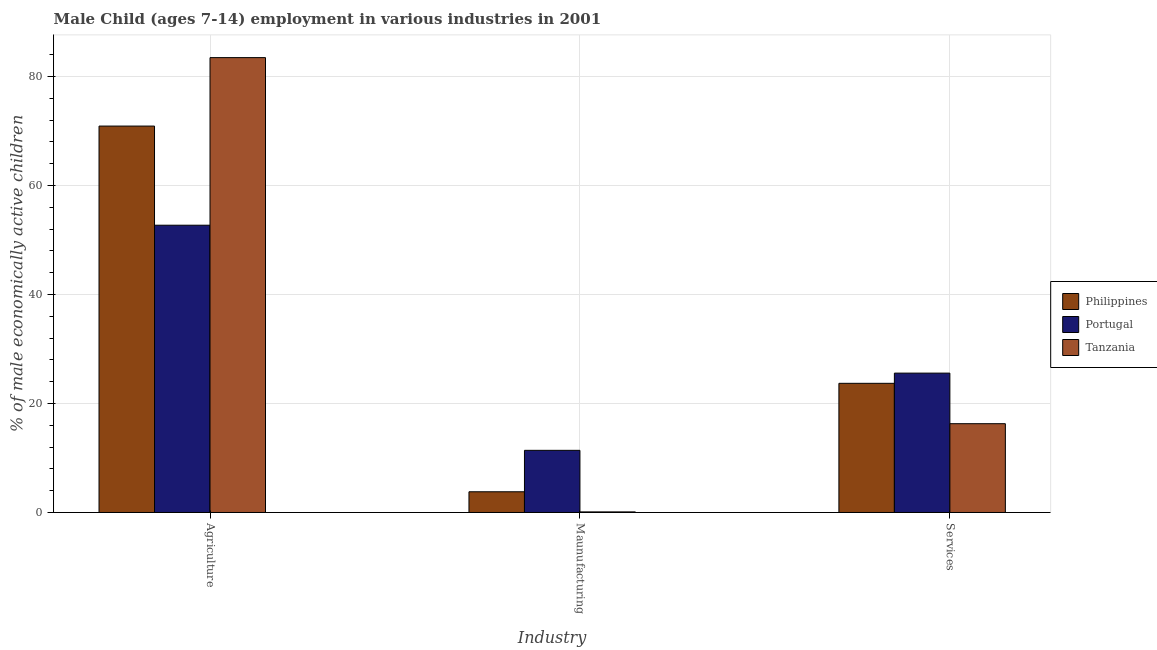How many groups of bars are there?
Ensure brevity in your answer.  3. Are the number of bars on each tick of the X-axis equal?
Your answer should be very brief. Yes. How many bars are there on the 1st tick from the right?
Keep it short and to the point. 3. What is the label of the 3rd group of bars from the left?
Give a very brief answer. Services. What is the percentage of economically active children in agriculture in Portugal?
Provide a short and direct response. 52.71. Across all countries, what is the maximum percentage of economically active children in services?
Make the answer very short. 25.57. Across all countries, what is the minimum percentage of economically active children in manufacturing?
Ensure brevity in your answer.  0.11. In which country was the percentage of economically active children in agriculture maximum?
Keep it short and to the point. Tanzania. In which country was the percentage of economically active children in services minimum?
Your answer should be compact. Tanzania. What is the total percentage of economically active children in manufacturing in the graph?
Ensure brevity in your answer.  15.31. What is the difference between the percentage of economically active children in agriculture in Portugal and that in Philippines?
Ensure brevity in your answer.  -18.19. What is the difference between the percentage of economically active children in services in Philippines and the percentage of economically active children in manufacturing in Portugal?
Provide a short and direct response. 12.3. What is the average percentage of economically active children in services per country?
Your answer should be compact. 21.85. What is the difference between the percentage of economically active children in services and percentage of economically active children in agriculture in Portugal?
Offer a terse response. -27.14. In how many countries, is the percentage of economically active children in services greater than 20 %?
Provide a succinct answer. 2. What is the ratio of the percentage of economically active children in manufacturing in Philippines to that in Portugal?
Your answer should be very brief. 0.33. Is the percentage of economically active children in services in Philippines less than that in Tanzania?
Offer a very short reply. No. Is the difference between the percentage of economically active children in agriculture in Portugal and Philippines greater than the difference between the percentage of economically active children in services in Portugal and Philippines?
Your answer should be very brief. No. What is the difference between the highest and the second highest percentage of economically active children in services?
Ensure brevity in your answer.  1.87. What is the difference between the highest and the lowest percentage of economically active children in agriculture?
Offer a very short reply. 30.75. In how many countries, is the percentage of economically active children in manufacturing greater than the average percentage of economically active children in manufacturing taken over all countries?
Ensure brevity in your answer.  1. Is the sum of the percentage of economically active children in manufacturing in Tanzania and Portugal greater than the maximum percentage of economically active children in agriculture across all countries?
Offer a very short reply. No. What does the 3rd bar from the left in Agriculture represents?
Make the answer very short. Tanzania. What does the 1st bar from the right in Services represents?
Your answer should be compact. Tanzania. Is it the case that in every country, the sum of the percentage of economically active children in agriculture and percentage of economically active children in manufacturing is greater than the percentage of economically active children in services?
Ensure brevity in your answer.  Yes. How many bars are there?
Offer a terse response. 9. Are all the bars in the graph horizontal?
Your answer should be compact. No. What is the difference between two consecutive major ticks on the Y-axis?
Provide a short and direct response. 20. What is the title of the graph?
Make the answer very short. Male Child (ages 7-14) employment in various industries in 2001. Does "Chile" appear as one of the legend labels in the graph?
Your answer should be very brief. No. What is the label or title of the X-axis?
Provide a short and direct response. Industry. What is the label or title of the Y-axis?
Keep it short and to the point. % of male economically active children. What is the % of male economically active children in Philippines in Agriculture?
Offer a very short reply. 70.9. What is the % of male economically active children in Portugal in Agriculture?
Offer a very short reply. 52.71. What is the % of male economically active children of Tanzania in Agriculture?
Your answer should be very brief. 83.46. What is the % of male economically active children of Portugal in Maunufacturing?
Provide a short and direct response. 11.4. What is the % of male economically active children in Tanzania in Maunufacturing?
Provide a short and direct response. 0.11. What is the % of male economically active children of Philippines in Services?
Offer a very short reply. 23.7. What is the % of male economically active children in Portugal in Services?
Offer a terse response. 25.57. What is the % of male economically active children of Tanzania in Services?
Offer a terse response. 16.29. Across all Industry, what is the maximum % of male economically active children of Philippines?
Offer a terse response. 70.9. Across all Industry, what is the maximum % of male economically active children in Portugal?
Provide a succinct answer. 52.71. Across all Industry, what is the maximum % of male economically active children of Tanzania?
Offer a very short reply. 83.46. Across all Industry, what is the minimum % of male economically active children of Philippines?
Provide a short and direct response. 3.8. Across all Industry, what is the minimum % of male economically active children of Portugal?
Offer a very short reply. 11.4. Across all Industry, what is the minimum % of male economically active children of Tanzania?
Give a very brief answer. 0.11. What is the total % of male economically active children of Philippines in the graph?
Keep it short and to the point. 98.4. What is the total % of male economically active children of Portugal in the graph?
Ensure brevity in your answer.  89.68. What is the total % of male economically active children of Tanzania in the graph?
Keep it short and to the point. 99.86. What is the difference between the % of male economically active children of Philippines in Agriculture and that in Maunufacturing?
Provide a succinct answer. 67.1. What is the difference between the % of male economically active children of Portugal in Agriculture and that in Maunufacturing?
Provide a short and direct response. 41.31. What is the difference between the % of male economically active children in Tanzania in Agriculture and that in Maunufacturing?
Offer a very short reply. 83.35. What is the difference between the % of male economically active children in Philippines in Agriculture and that in Services?
Offer a very short reply. 47.2. What is the difference between the % of male economically active children in Portugal in Agriculture and that in Services?
Keep it short and to the point. 27.14. What is the difference between the % of male economically active children of Tanzania in Agriculture and that in Services?
Your answer should be very brief. 67.17. What is the difference between the % of male economically active children in Philippines in Maunufacturing and that in Services?
Your answer should be compact. -19.9. What is the difference between the % of male economically active children in Portugal in Maunufacturing and that in Services?
Ensure brevity in your answer.  -14.17. What is the difference between the % of male economically active children in Tanzania in Maunufacturing and that in Services?
Give a very brief answer. -16.18. What is the difference between the % of male economically active children of Philippines in Agriculture and the % of male economically active children of Portugal in Maunufacturing?
Ensure brevity in your answer.  59.5. What is the difference between the % of male economically active children of Philippines in Agriculture and the % of male economically active children of Tanzania in Maunufacturing?
Keep it short and to the point. 70.79. What is the difference between the % of male economically active children in Portugal in Agriculture and the % of male economically active children in Tanzania in Maunufacturing?
Provide a succinct answer. 52.6. What is the difference between the % of male economically active children in Philippines in Agriculture and the % of male economically active children in Portugal in Services?
Give a very brief answer. 45.33. What is the difference between the % of male economically active children in Philippines in Agriculture and the % of male economically active children in Tanzania in Services?
Keep it short and to the point. 54.61. What is the difference between the % of male economically active children of Portugal in Agriculture and the % of male economically active children of Tanzania in Services?
Keep it short and to the point. 36.42. What is the difference between the % of male economically active children in Philippines in Maunufacturing and the % of male economically active children in Portugal in Services?
Your response must be concise. -21.77. What is the difference between the % of male economically active children in Philippines in Maunufacturing and the % of male economically active children in Tanzania in Services?
Ensure brevity in your answer.  -12.49. What is the difference between the % of male economically active children in Portugal in Maunufacturing and the % of male economically active children in Tanzania in Services?
Your answer should be compact. -4.89. What is the average % of male economically active children of Philippines per Industry?
Your response must be concise. 32.8. What is the average % of male economically active children of Portugal per Industry?
Keep it short and to the point. 29.89. What is the average % of male economically active children of Tanzania per Industry?
Provide a short and direct response. 33.29. What is the difference between the % of male economically active children of Philippines and % of male economically active children of Portugal in Agriculture?
Ensure brevity in your answer.  18.19. What is the difference between the % of male economically active children of Philippines and % of male economically active children of Tanzania in Agriculture?
Offer a terse response. -12.56. What is the difference between the % of male economically active children of Portugal and % of male economically active children of Tanzania in Agriculture?
Make the answer very short. -30.75. What is the difference between the % of male economically active children in Philippines and % of male economically active children in Portugal in Maunufacturing?
Offer a very short reply. -7.6. What is the difference between the % of male economically active children in Philippines and % of male economically active children in Tanzania in Maunufacturing?
Ensure brevity in your answer.  3.69. What is the difference between the % of male economically active children in Portugal and % of male economically active children in Tanzania in Maunufacturing?
Provide a short and direct response. 11.29. What is the difference between the % of male economically active children of Philippines and % of male economically active children of Portugal in Services?
Give a very brief answer. -1.87. What is the difference between the % of male economically active children of Philippines and % of male economically active children of Tanzania in Services?
Keep it short and to the point. 7.41. What is the difference between the % of male economically active children in Portugal and % of male economically active children in Tanzania in Services?
Your response must be concise. 9.28. What is the ratio of the % of male economically active children in Philippines in Agriculture to that in Maunufacturing?
Provide a short and direct response. 18.66. What is the ratio of the % of male economically active children in Portugal in Agriculture to that in Maunufacturing?
Provide a succinct answer. 4.62. What is the ratio of the % of male economically active children in Tanzania in Agriculture to that in Maunufacturing?
Give a very brief answer. 776.98. What is the ratio of the % of male economically active children of Philippines in Agriculture to that in Services?
Keep it short and to the point. 2.99. What is the ratio of the % of male economically active children in Portugal in Agriculture to that in Services?
Provide a short and direct response. 2.06. What is the ratio of the % of male economically active children of Tanzania in Agriculture to that in Services?
Make the answer very short. 5.12. What is the ratio of the % of male economically active children of Philippines in Maunufacturing to that in Services?
Keep it short and to the point. 0.16. What is the ratio of the % of male economically active children in Portugal in Maunufacturing to that in Services?
Your answer should be compact. 0.45. What is the ratio of the % of male economically active children of Tanzania in Maunufacturing to that in Services?
Ensure brevity in your answer.  0.01. What is the difference between the highest and the second highest % of male economically active children in Philippines?
Your answer should be compact. 47.2. What is the difference between the highest and the second highest % of male economically active children of Portugal?
Your response must be concise. 27.14. What is the difference between the highest and the second highest % of male economically active children in Tanzania?
Offer a terse response. 67.17. What is the difference between the highest and the lowest % of male economically active children of Philippines?
Your answer should be very brief. 67.1. What is the difference between the highest and the lowest % of male economically active children in Portugal?
Provide a succinct answer. 41.31. What is the difference between the highest and the lowest % of male economically active children of Tanzania?
Provide a succinct answer. 83.35. 